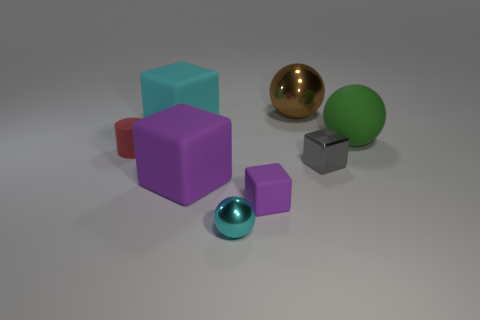Subtract all purple cubes. How many were subtracted if there are1purple cubes left? 1 Subtract 1 blocks. How many blocks are left? 3 Subtract all purple balls. How many purple cubes are left? 2 Subtract all large brown balls. How many balls are left? 2 Add 1 cyan things. How many objects exist? 9 Subtract all gray blocks. How many blocks are left? 3 Subtract all cylinders. How many objects are left? 7 Subtract all red balls. Subtract all gray cylinders. How many balls are left? 3 Add 1 big brown objects. How many big brown objects exist? 2 Subtract 0 green blocks. How many objects are left? 8 